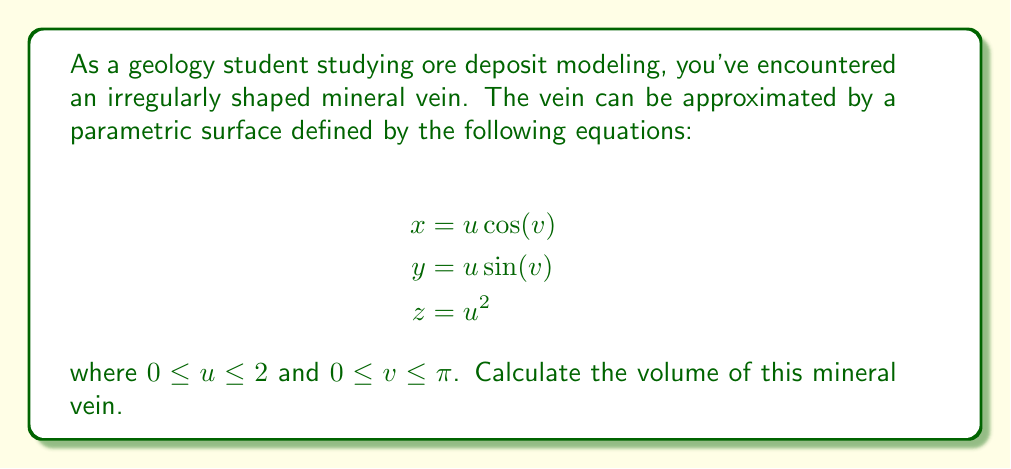Show me your answer to this math problem. To calculate the volume of the mineral vein described by the given parametric surface, we need to use the formula for the volume of a parametric surface:

$$V = \int\int\int |J| du dv dw$$

where $J$ is the Jacobian determinant.

Step 1: Calculate the Jacobian determinant.
The Jacobian matrix is:

$$J = \begin{vmatrix}
\frac{\partial x}{\partial u} & \frac{\partial x}{\partial v} \\
\frac{\partial y}{\partial u} & \frac{\partial y}{\partial v} \\
\frac{\partial z}{\partial u} & \frac{\partial z}{\partial v}
\end{vmatrix}$$

Calculating the partial derivatives:
$$\frac{\partial x}{\partial u} = \cos(v)$$
$$\frac{\partial x}{\partial v} = -u \sin(v)$$
$$\frac{\partial y}{\partial u} = \sin(v)$$
$$\frac{\partial y}{\partial v} = u \cos(v)$$
$$\frac{\partial z}{\partial u} = 2u$$
$$\frac{\partial z}{\partial v} = 0$$

The Jacobian determinant is:

$$|J| = \left|\begin{vmatrix}
\cos(v) & -u \sin(v) \\
\sin(v) & u \cos(v) \\
2u & 0
\end{vmatrix}\right| = 2u(\cos^2(v) + \sin^2(v)) = 2u$$

Step 2: Set up the triple integral.
We need to integrate over $u$, $v$, and an additional variable $w$ that goes from 0 to 1 to create the volume:

$$V = \int_0^1 \int_0^\pi \int_0^2 2u \, du \, dv \, dw$$

Step 3: Evaluate the triple integral.
First, integrate with respect to $u$:

$$V = \int_0^1 \int_0^\pi \left[u^2\right]_0^2 \, dv \, dw = \int_0^1 \int_0^\pi 4 \, dv \, dw$$

Now, integrate with respect to $v$:

$$V = \int_0^1 \left[4v\right]_0^\pi \, dw = \int_0^1 4\pi \, dw$$

Finally, integrate with respect to $w$:

$$V = \left[4\pi w\right]_0^1 = 4\pi$$

Therefore, the volume of the mineral vein is $4\pi$ cubic units.
Answer: $4\pi$ cubic units 